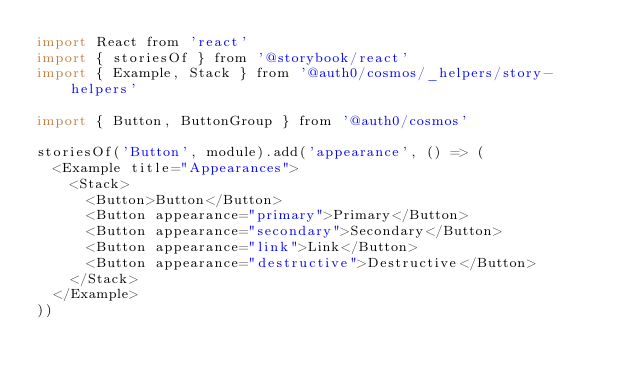Convert code to text. <code><loc_0><loc_0><loc_500><loc_500><_JavaScript_>import React from 'react'
import { storiesOf } from '@storybook/react'
import { Example, Stack } from '@auth0/cosmos/_helpers/story-helpers'

import { Button, ButtonGroup } from '@auth0/cosmos'

storiesOf('Button', module).add('appearance', () => (
  <Example title="Appearances">
    <Stack>
      <Button>Button</Button>
      <Button appearance="primary">Primary</Button>
      <Button appearance="secondary">Secondary</Button>
      <Button appearance="link">Link</Button>
      <Button appearance="destructive">Destructive</Button>
    </Stack>
  </Example>
))
</code> 